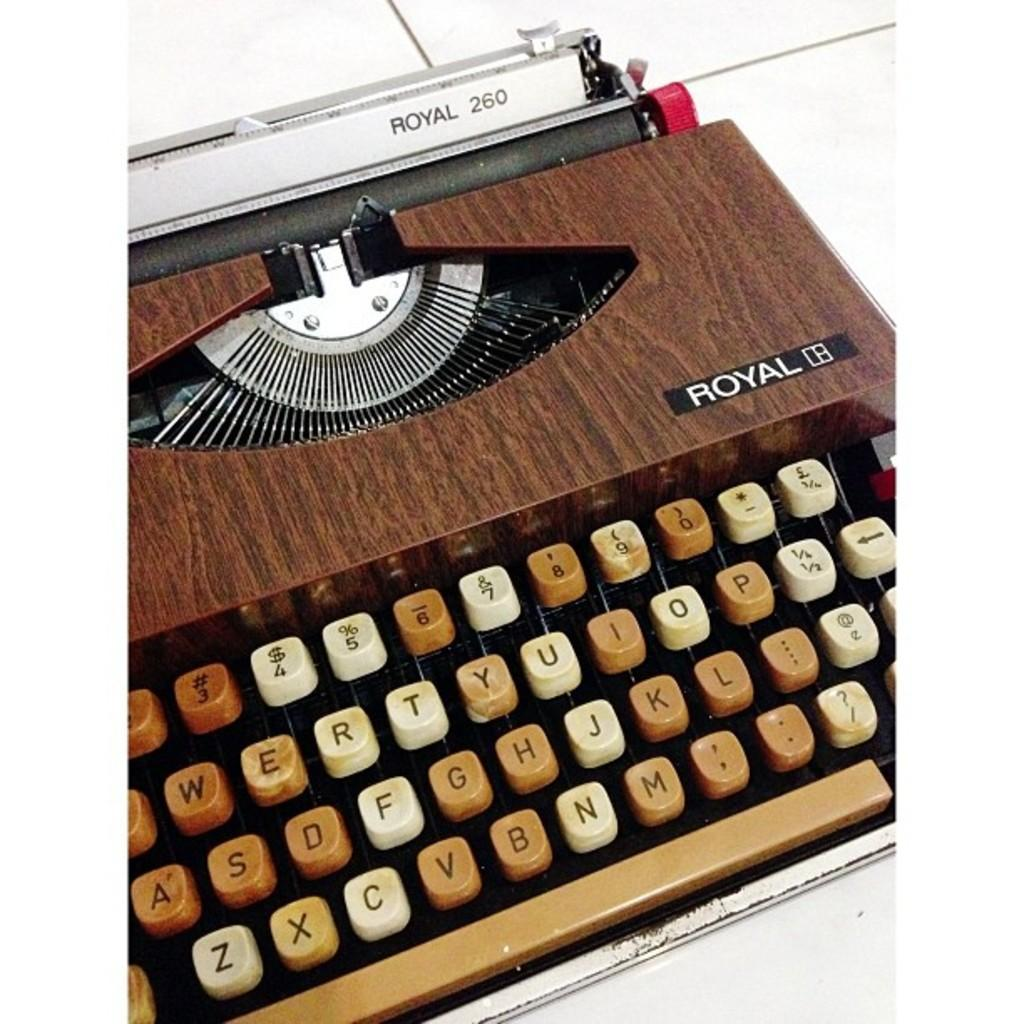Provide a one-sentence caption for the provided image. A Vintage wood grain Royal 260 model typewriter. 